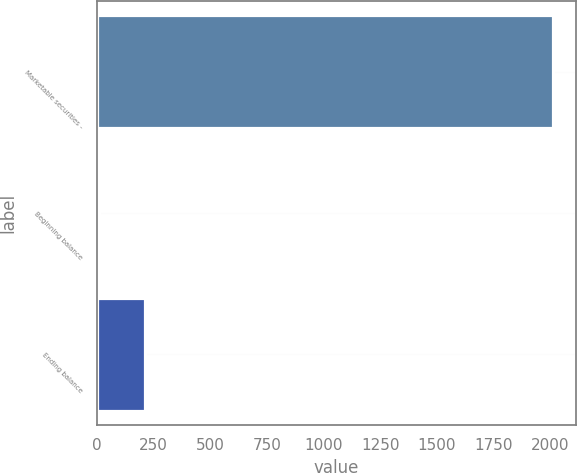<chart> <loc_0><loc_0><loc_500><loc_500><bar_chart><fcel>Marketable securities -<fcel>Beginning balance<fcel>Ending balance<nl><fcel>2014<fcel>11<fcel>211.3<nl></chart> 